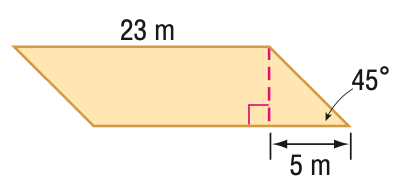Answer the mathemtical geometry problem and directly provide the correct option letter.
Question: Find the area of the parallelogram. Round to the nearest tenth if necessary.
Choices: A: 57.5 B: 81.3 C: 99.6 D: 115 D 